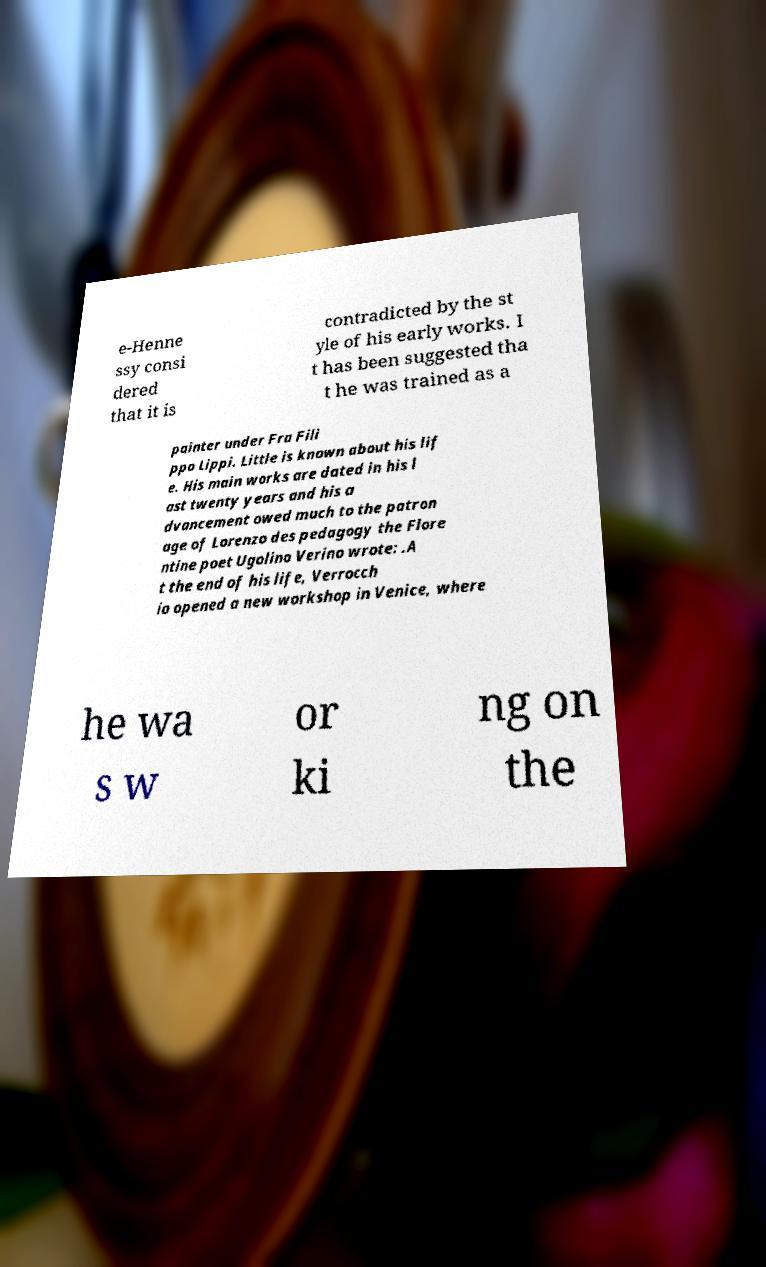For documentation purposes, I need the text within this image transcribed. Could you provide that? e-Henne ssy consi dered that it is contradicted by the st yle of his early works. I t has been suggested tha t he was trained as a painter under Fra Fili ppo Lippi. Little is known about his lif e. His main works are dated in his l ast twenty years and his a dvancement owed much to the patron age of Lorenzo des pedagogy the Flore ntine poet Ugolino Verino wrote: .A t the end of his life, Verrocch io opened a new workshop in Venice, where he wa s w or ki ng on the 